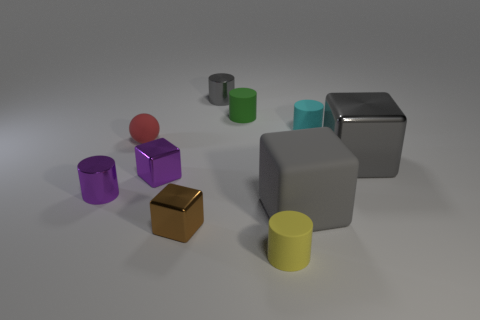Subtract 1 cylinders. How many cylinders are left? 4 Subtract all purple cylinders. How many cylinders are left? 4 Subtract all green cylinders. How many cylinders are left? 4 Subtract all yellow cylinders. Subtract all cyan cubes. How many cylinders are left? 4 Subtract all cubes. How many objects are left? 6 Add 9 small purple cylinders. How many small purple cylinders exist? 10 Subtract 0 yellow balls. How many objects are left? 10 Subtract all small blocks. Subtract all gray cylinders. How many objects are left? 7 Add 2 tiny yellow matte cylinders. How many tiny yellow matte cylinders are left? 3 